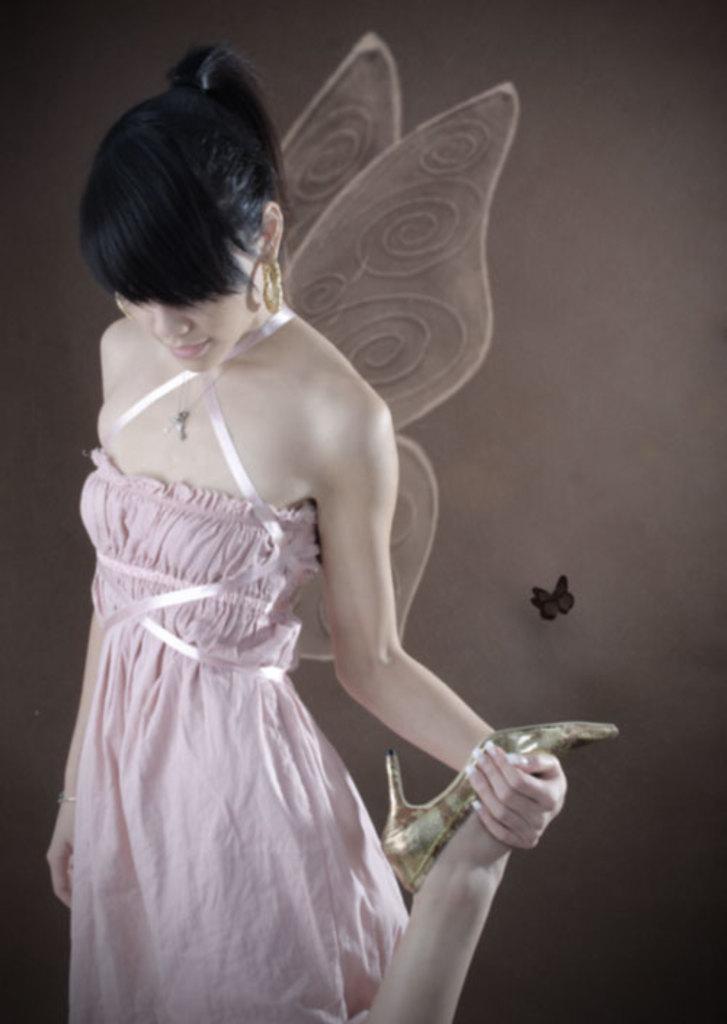Could you give a brief overview of what you see in this image? In this picture I can see a woman with wings, is standing and holding her leg, and in the background there is a butterfly on the wall. 